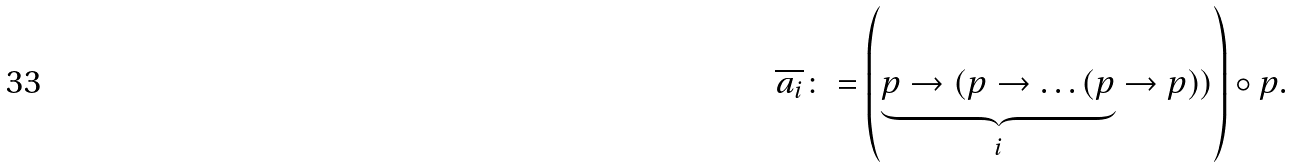Convert formula to latex. <formula><loc_0><loc_0><loc_500><loc_500>\overline { a _ { i } } \colon = \left ( \underbrace { p \to ( p \to \dots ( p } _ { i } \to p ) ) \right ) \circ p .</formula> 